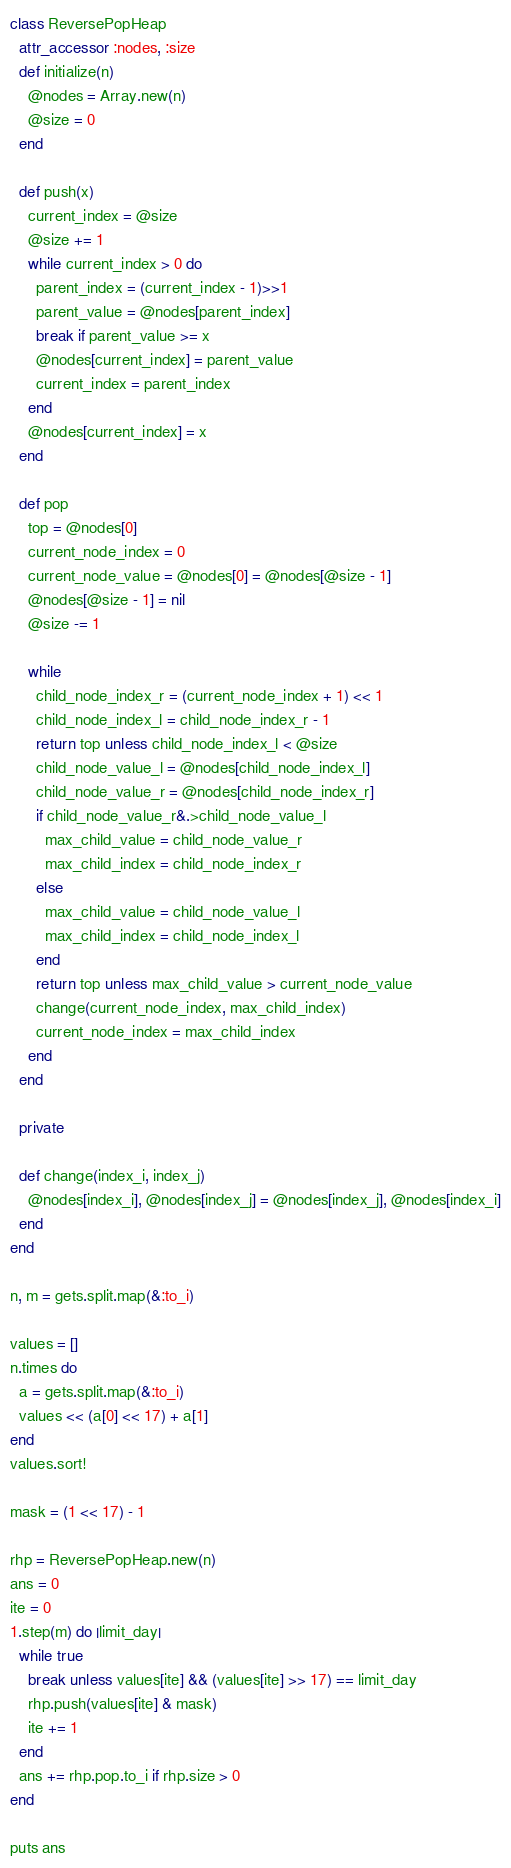Convert code to text. <code><loc_0><loc_0><loc_500><loc_500><_Ruby_>class ReversePopHeap
  attr_accessor :nodes, :size
  def initialize(n)
    @nodes = Array.new(n)
    @size = 0
  end

  def push(x)
    current_index = @size
    @size += 1
    while current_index > 0 do
      parent_index = (current_index - 1)>>1
      parent_value = @nodes[parent_index]
      break if parent_value >= x
      @nodes[current_index] = parent_value
      current_index = parent_index
    end
    @nodes[current_index] = x
  end

  def pop
    top = @nodes[0]
    current_node_index = 0
    current_node_value = @nodes[0] = @nodes[@size - 1]
    @nodes[@size - 1] = nil
    @size -= 1

    while
      child_node_index_r = (current_node_index + 1) << 1
      child_node_index_l = child_node_index_r - 1
      return top unless child_node_index_l < @size
      child_node_value_l = @nodes[child_node_index_l]
      child_node_value_r = @nodes[child_node_index_r]
      if child_node_value_r&.>child_node_value_l
        max_child_value = child_node_value_r
        max_child_index = child_node_index_r
      else
        max_child_value = child_node_value_l
        max_child_index = child_node_index_l
      end
      return top unless max_child_value > current_node_value
      change(current_node_index, max_child_index)
      current_node_index = max_child_index
    end
  end

  private

  def change(index_i, index_j)
    @nodes[index_i], @nodes[index_j] = @nodes[index_j], @nodes[index_i]
  end
end

n, m = gets.split.map(&:to_i)

values = []
n.times do
  a = gets.split.map(&:to_i)
  values << (a[0] << 17) + a[1]
end
values.sort!

mask = (1 << 17) - 1

rhp = ReversePopHeap.new(n)
ans = 0
ite = 0
1.step(m) do |limit_day|
  while true
    break unless values[ite] && (values[ite] >> 17) == limit_day
    rhp.push(values[ite] & mask)
    ite += 1
  end
  ans += rhp.pop.to_i if rhp.size > 0
end

puts ans</code> 